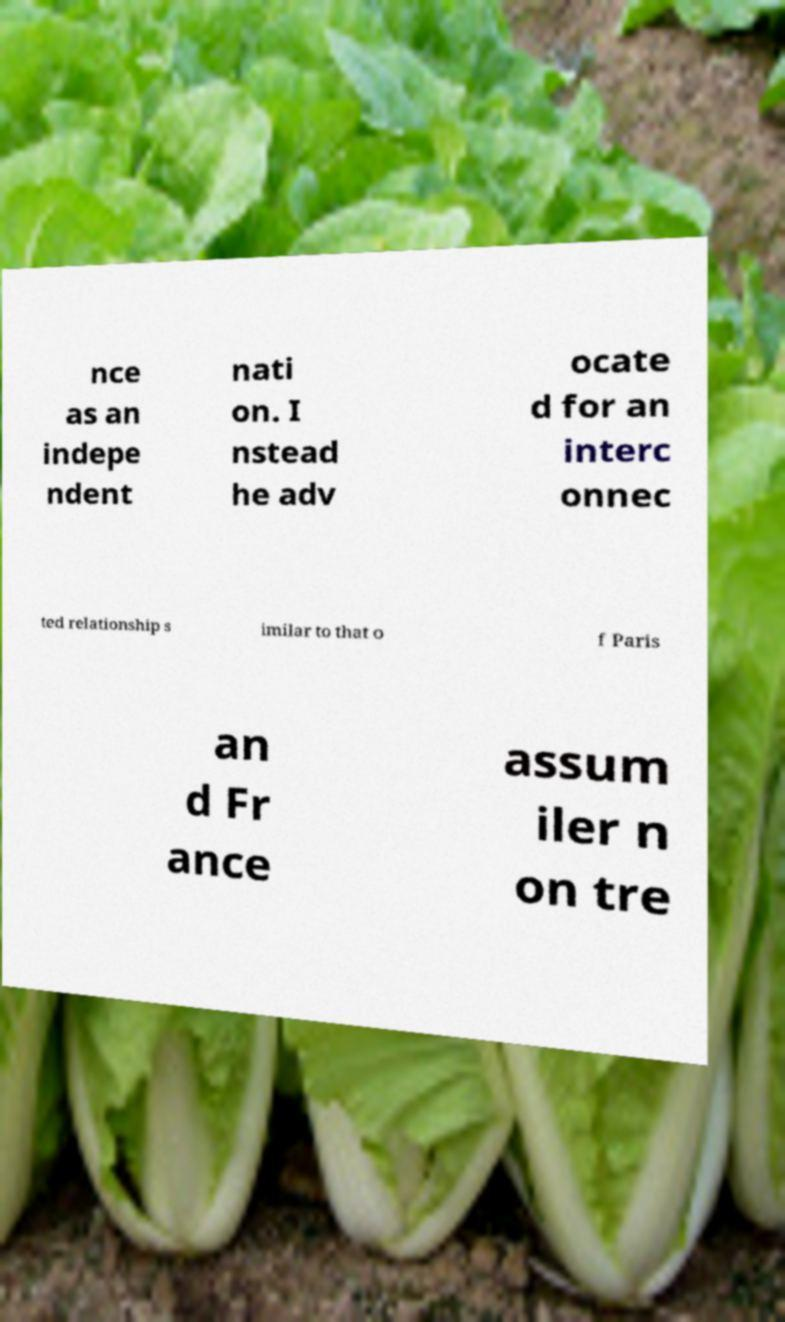What messages or text are displayed in this image? I need them in a readable, typed format. nce as an indepe ndent nati on. I nstead he adv ocate d for an interc onnec ted relationship s imilar to that o f Paris an d Fr ance assum iler n on tre 